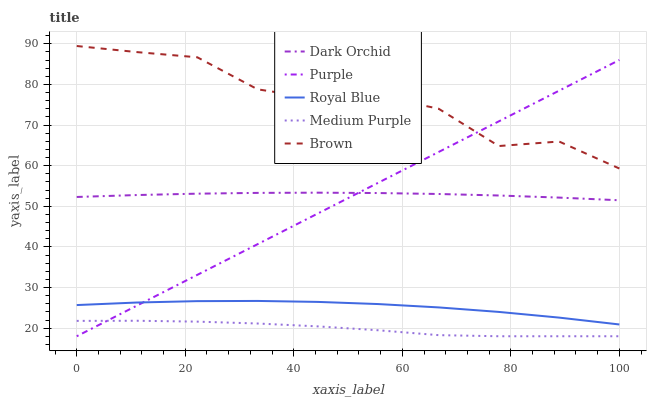Does Royal Blue have the minimum area under the curve?
Answer yes or no. No. Does Royal Blue have the maximum area under the curve?
Answer yes or no. No. Is Royal Blue the smoothest?
Answer yes or no. No. Is Royal Blue the roughest?
Answer yes or no. No. Does Royal Blue have the lowest value?
Answer yes or no. No. Does Royal Blue have the highest value?
Answer yes or no. No. Is Royal Blue less than Brown?
Answer yes or no. Yes. Is Brown greater than Medium Purple?
Answer yes or no. Yes. Does Royal Blue intersect Brown?
Answer yes or no. No. 